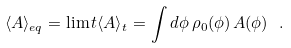<formula> <loc_0><loc_0><loc_500><loc_500>\langle A \rangle _ { e q } = \lim t \langle A \rangle _ { t } = \int d \phi \, \rho _ { 0 } ( \phi ) \, \AA A ( \phi ) \ .</formula> 